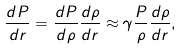<formula> <loc_0><loc_0><loc_500><loc_500>\frac { d P } { d r } = \frac { d P } { d \rho } \frac { d \rho } { d r } \approx \gamma \frac { P } { \rho } \frac { d \rho } { d r } ,</formula> 